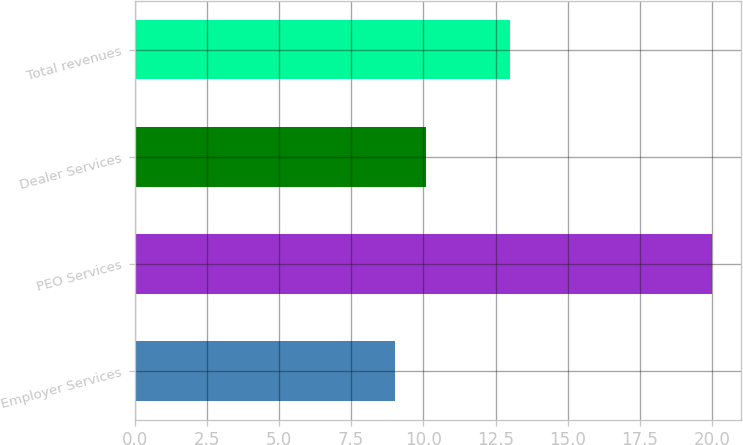<chart> <loc_0><loc_0><loc_500><loc_500><bar_chart><fcel>Employer Services<fcel>PEO Services<fcel>Dealer Services<fcel>Total revenues<nl><fcel>9<fcel>20<fcel>10.1<fcel>13<nl></chart> 